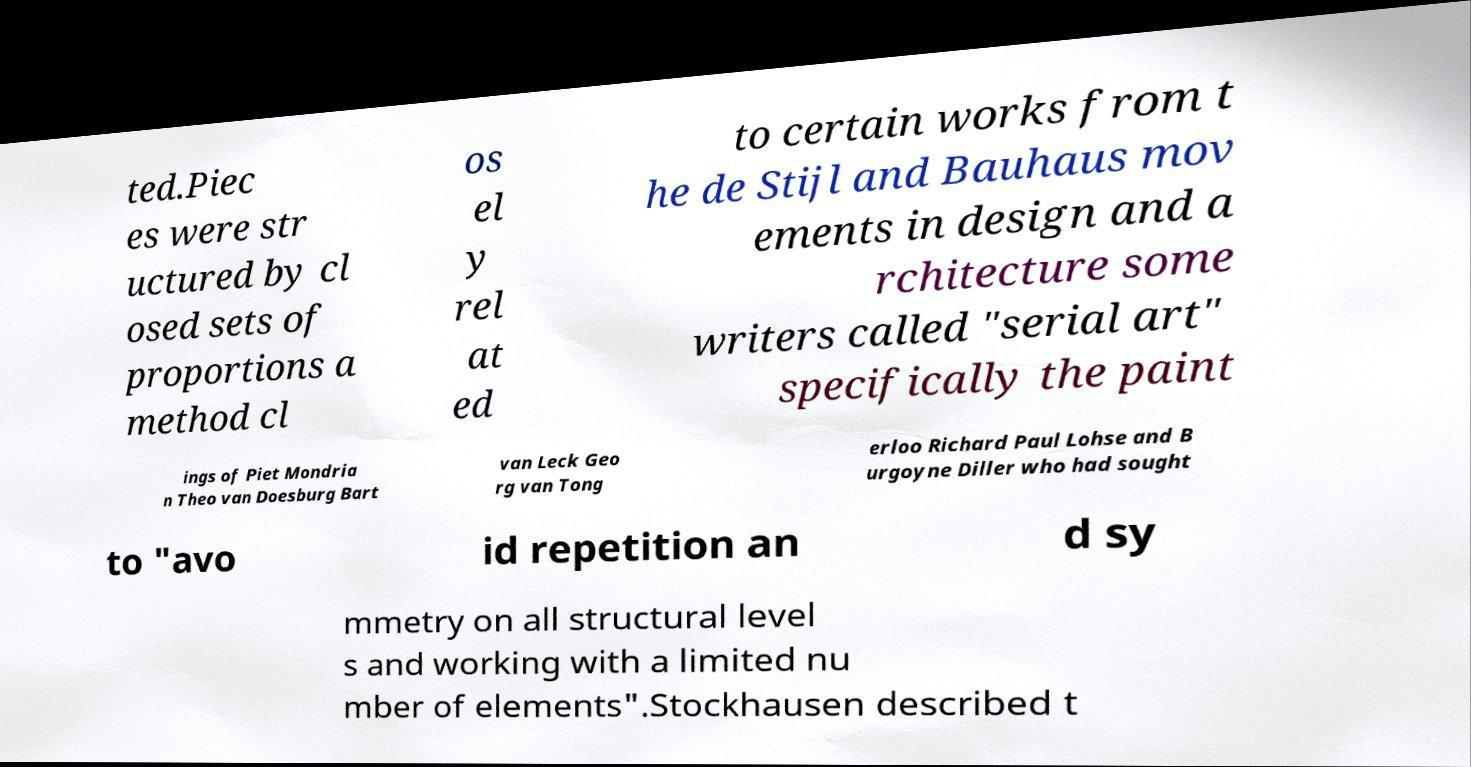Can you read and provide the text displayed in the image?This photo seems to have some interesting text. Can you extract and type it out for me? ted.Piec es were str uctured by cl osed sets of proportions a method cl os el y rel at ed to certain works from t he de Stijl and Bauhaus mov ements in design and a rchitecture some writers called "serial art" specifically the paint ings of Piet Mondria n Theo van Doesburg Bart van Leck Geo rg van Tong erloo Richard Paul Lohse and B urgoyne Diller who had sought to "avo id repetition an d sy mmetry on all structural level s and working with a limited nu mber of elements".Stockhausen described t 